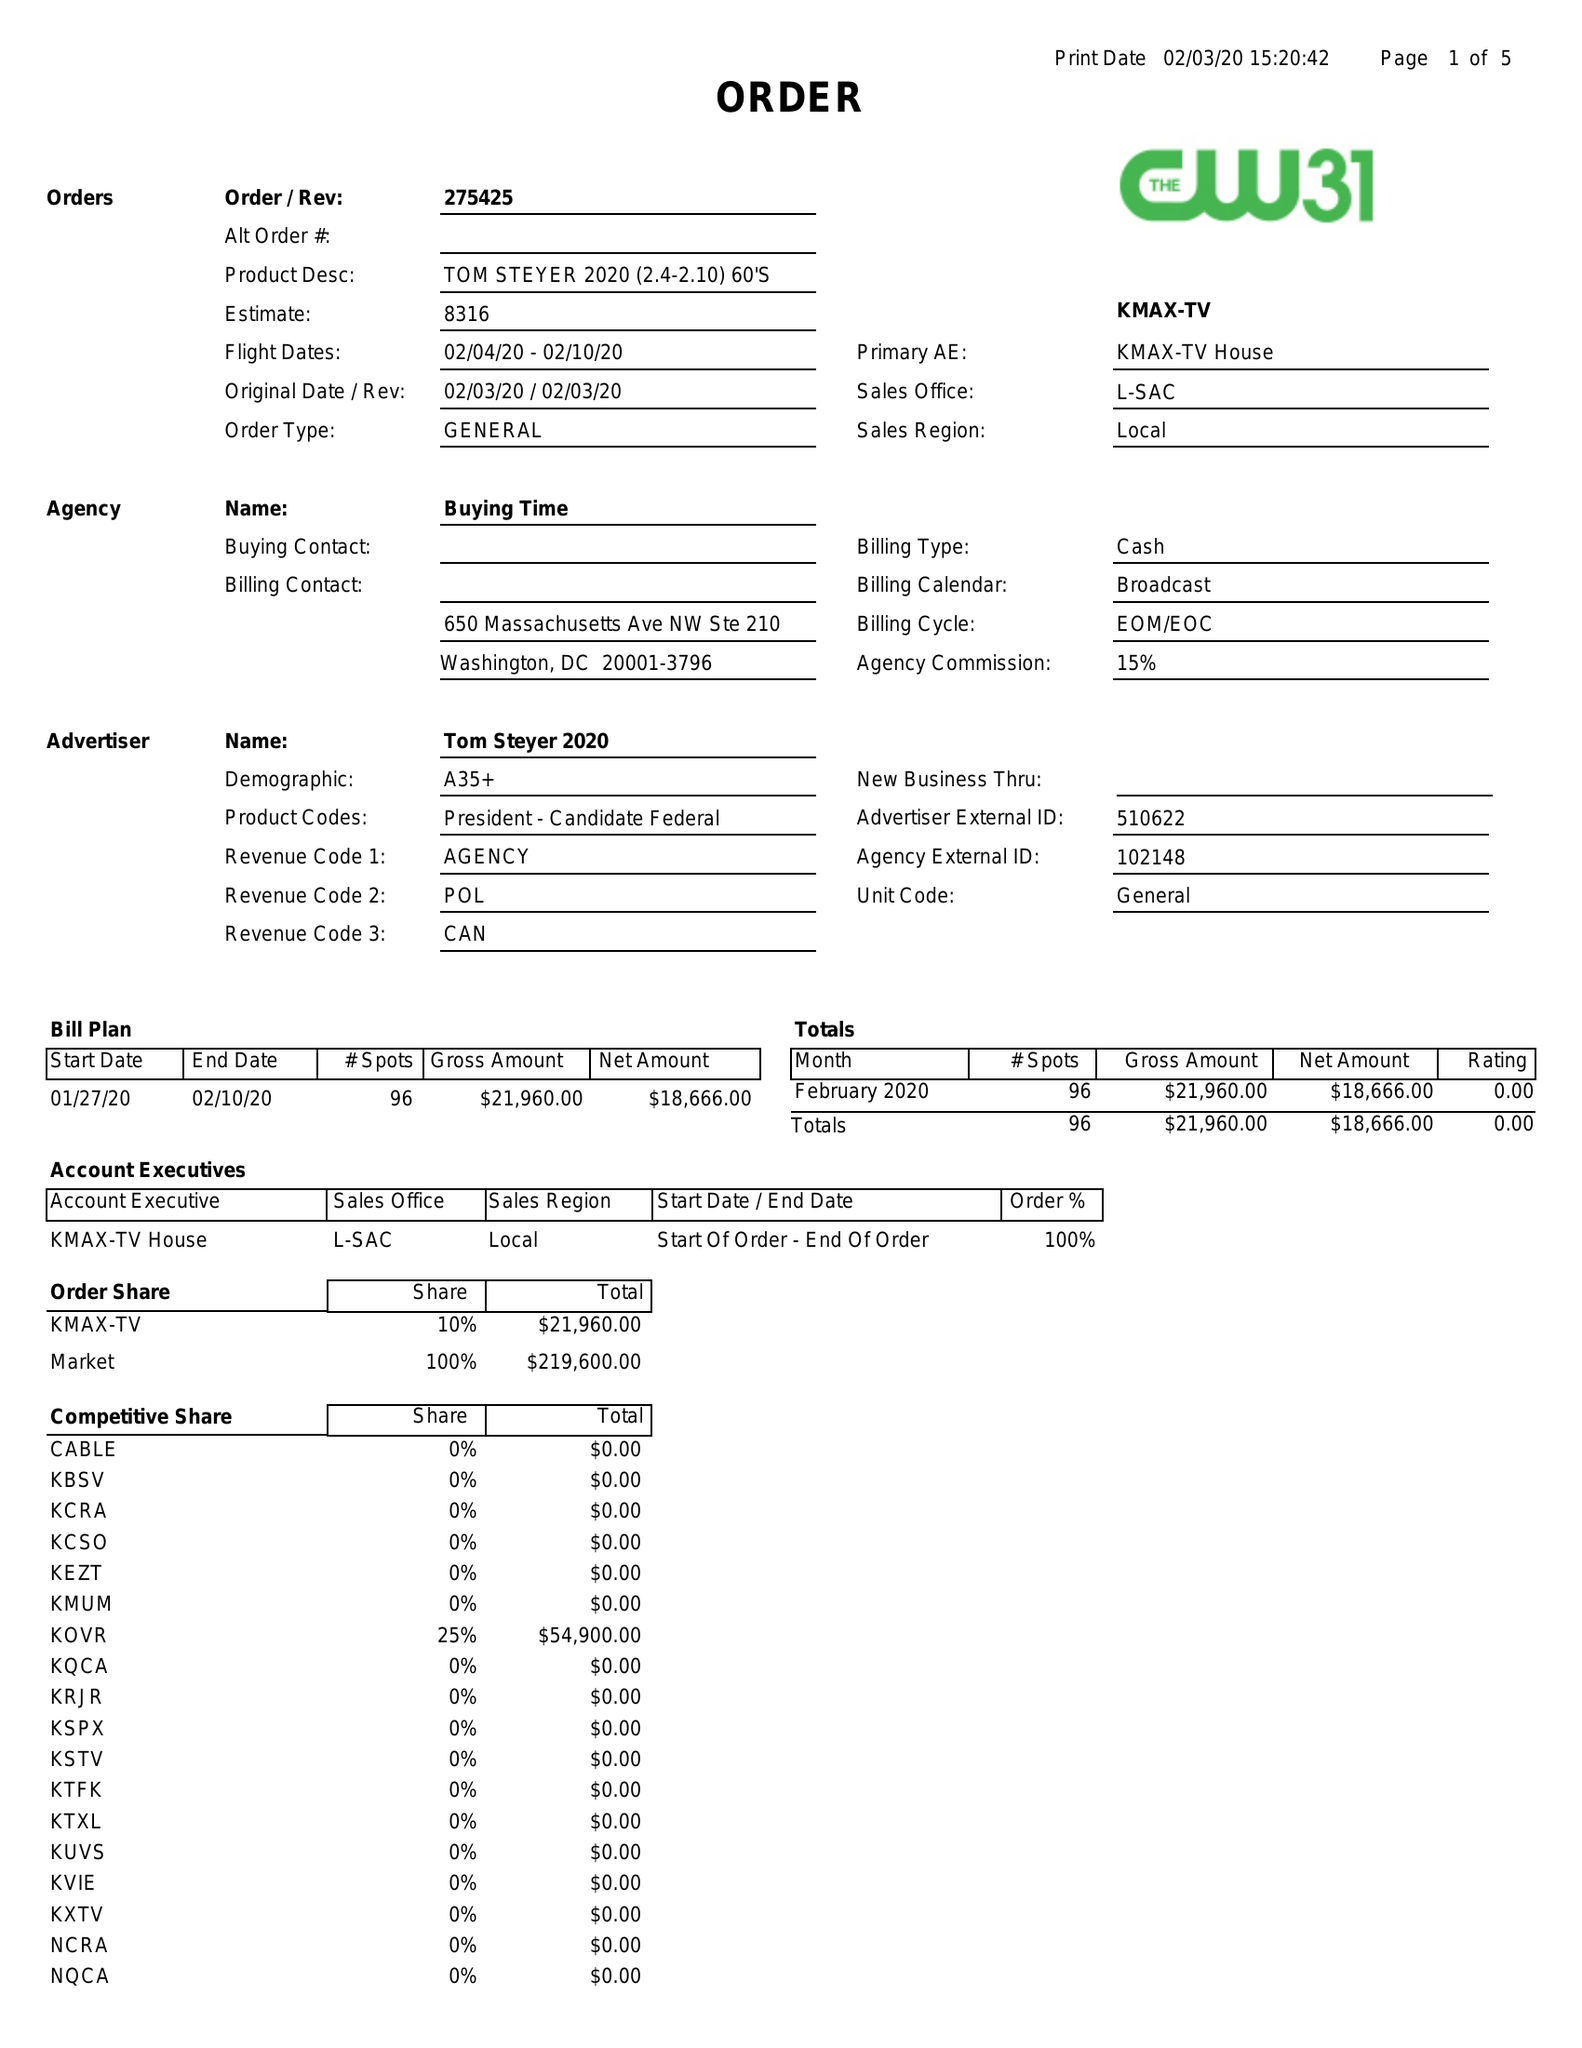What is the value for the flight_to?
Answer the question using a single word or phrase. 02/10/20 